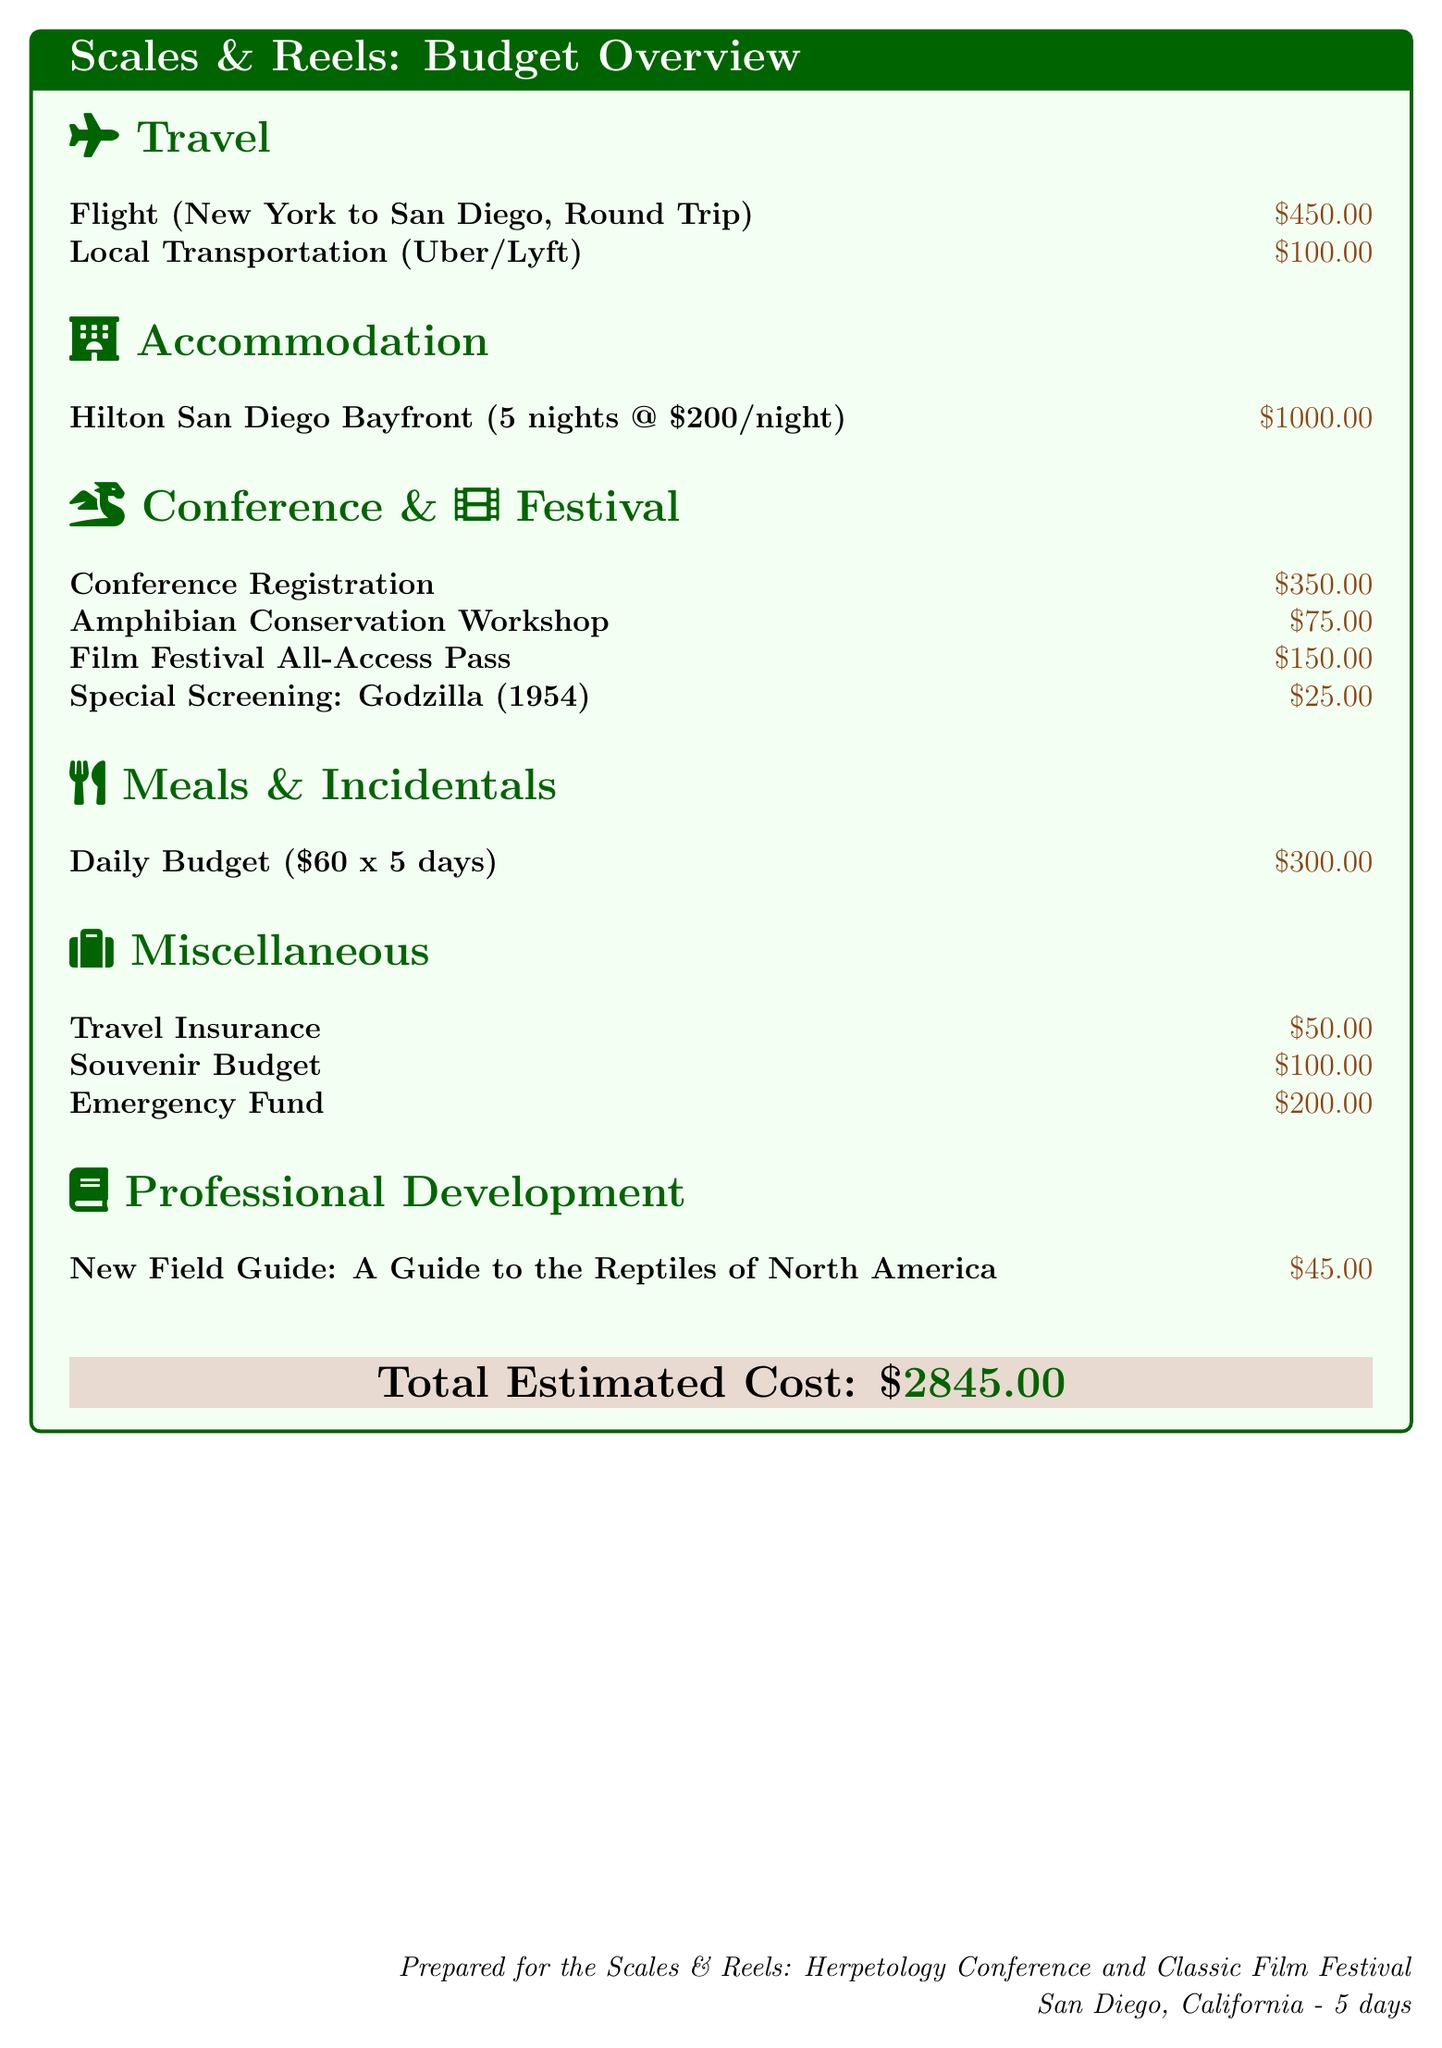What is the total estimated cost? The total estimated cost is presented at the end of the budget overview.
Answer: $2845.00 How much is the flight from New York to San Diego? The flight cost is listed under the travel section.
Answer: $450.00 What is the accommodation cost per night? The accommodation cost is calculated based on the total cost for 5 nights divided by the number of nights.
Answer: $200/night What is the registration fee for the conference? The conference registration fee is explicitly stated in the document.
Answer: $350.00 How much does the film festival all-access pass cost? The cost of the film festival all-access pass is provided under the conference and film festival section.
Answer: $150.00 What is the daily budget allotted for meals? The daily budget for meals is shown under the meals and incidentals section.
Answer: $60 How many nights will the conference attendee stay? The number of nights for accommodation is specified in the travel section.
Answer: 5 nights What is included in the miscellaneous budget? The miscellaneous section lists multiple items, including travel insurance and souvenir budget.
Answer: Travel Insurance, Souvenir Budget, Emergency Fund What workshop is mentioned in the budget? The document specifically mentions one workshop regarding amphibian conservation.
Answer: Amphibian Conservation Workshop 